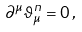<formula> <loc_0><loc_0><loc_500><loc_500>\partial ^ { \mu } \vartheta _ { \mu } ^ { n } = 0 \, ,</formula> 